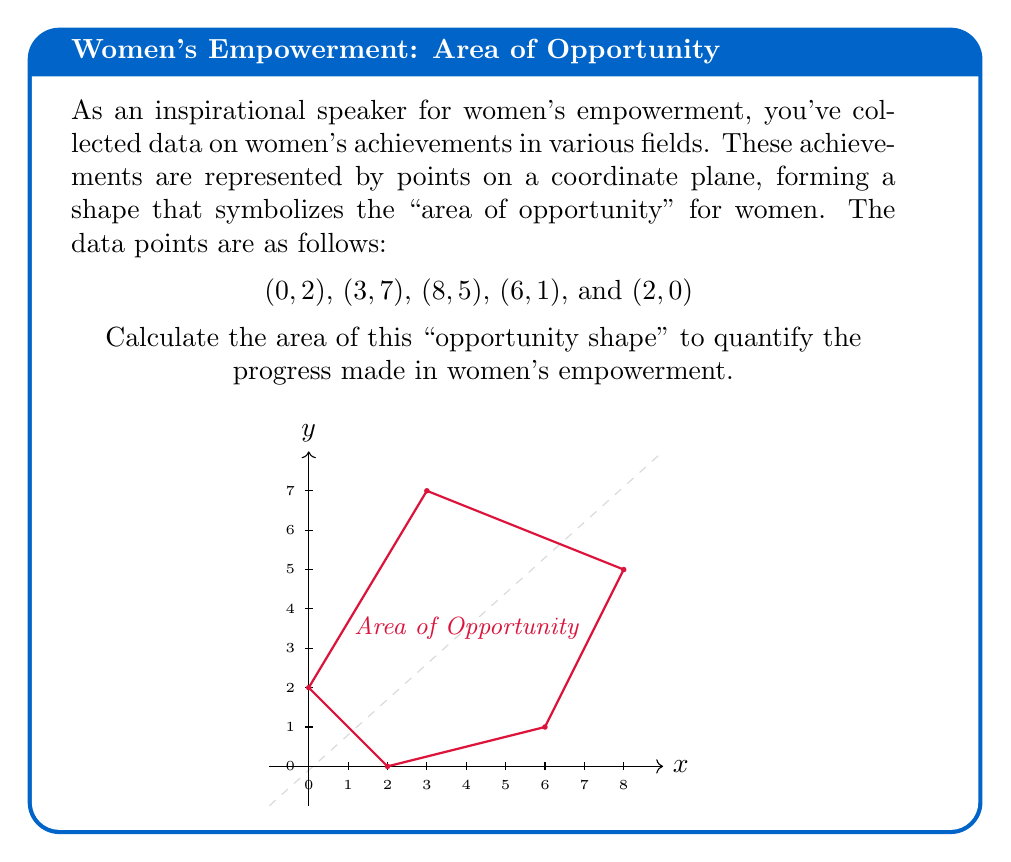Give your solution to this math problem. To find the area of this irregular polygon, we can use the Shoelace formula (also known as the surveyor's formula). This method calculates the area of a polygon given the coordinates of its vertices.

The formula is:

$$ A = \frac{1}{2}|\sum_{i=1}^{n-1} (x_iy_{i+1} + x_ny_1) - \sum_{i=1}^{n-1} (y_ix_{i+1} + y_nx_1)| $$

Where $(x_i, y_i)$ are the coordinates of the $i$-th vertex.

Let's apply this formula to our data points:

1) First, let's order our points: (0,2), (3,7), (8,5), (6,1), (2,0)

2) Now, let's calculate the first sum:
   $$(0 \cdot 7) + (3 \cdot 5) + (8 \cdot 1) + (6 \cdot 0) + (2 \cdot 2) = 0 + 15 + 8 + 0 + 4 = 27$$

3) Calculate the second sum:
   $$(2 \cdot 3) + (7 \cdot 8) + (5 \cdot 6) + (1 \cdot 2) + (0 \cdot 0) = 6 + 56 + 30 + 2 + 0 = 94$$

4) Subtract the second sum from the first:
   $$27 - 94 = -67$$

5) Take the absolute value and divide by 2:
   $$\frac{1}{2}|-67| = \frac{67}{2} = 33.5$$

Therefore, the area of the "opportunity shape" is 33.5 square units.
Answer: 33.5 square units 